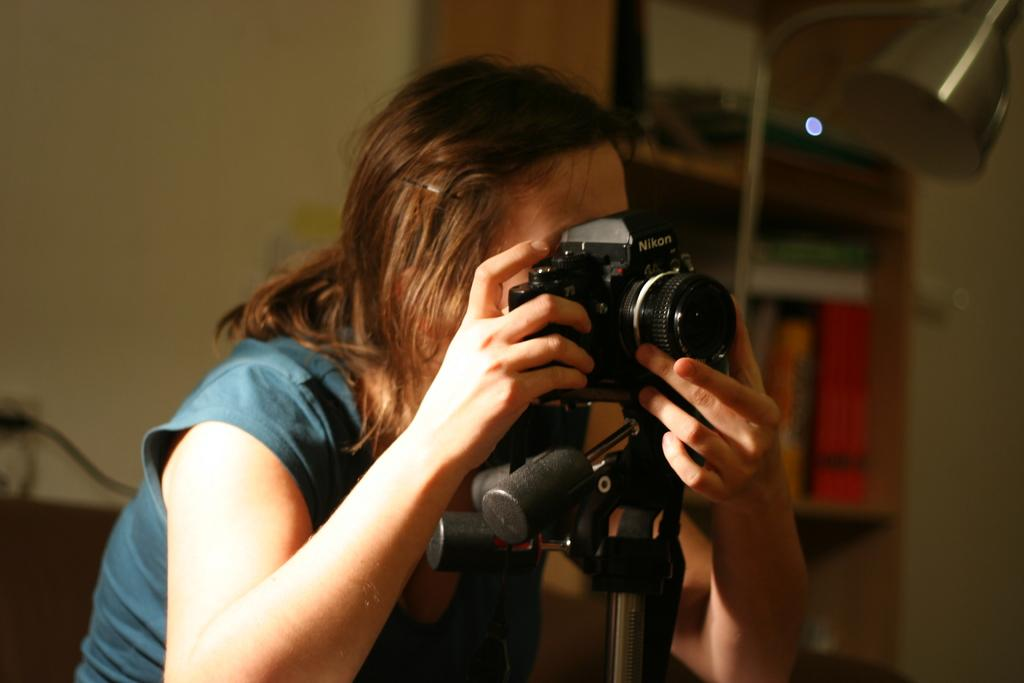Who is present in the image? There is a woman in the image. What is the woman holding in the image? The woman is holding a camera. What type of stamp can be seen on the notebook in the image? There is no stamp or notebook present in the image; it only features a woman holding a camera. 